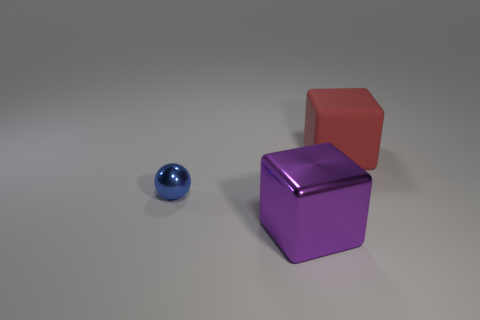Add 3 green shiny spheres. How many objects exist? 6 Subtract all purple blocks. How many blocks are left? 1 Subtract all blocks. How many objects are left? 1 Subtract 1 spheres. How many spheres are left? 0 Subtract all cyan cylinders. How many red cubes are left? 1 Subtract all balls. Subtract all small blue metal objects. How many objects are left? 1 Add 1 large objects. How many large objects are left? 3 Add 2 purple blocks. How many purple blocks exist? 3 Subtract 0 yellow cylinders. How many objects are left? 3 Subtract all red cubes. Subtract all green cylinders. How many cubes are left? 1 